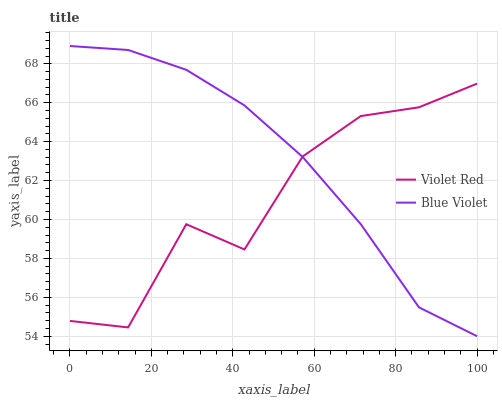Does Violet Red have the minimum area under the curve?
Answer yes or no. Yes. Does Blue Violet have the maximum area under the curve?
Answer yes or no. Yes. Does Blue Violet have the minimum area under the curve?
Answer yes or no. No. Is Blue Violet the smoothest?
Answer yes or no. Yes. Is Violet Red the roughest?
Answer yes or no. Yes. Is Blue Violet the roughest?
Answer yes or no. No. Does Blue Violet have the lowest value?
Answer yes or no. Yes. Does Blue Violet have the highest value?
Answer yes or no. Yes. Does Blue Violet intersect Violet Red?
Answer yes or no. Yes. Is Blue Violet less than Violet Red?
Answer yes or no. No. Is Blue Violet greater than Violet Red?
Answer yes or no. No. 